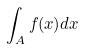<formula> <loc_0><loc_0><loc_500><loc_500>\int _ { A } f ( x ) d x</formula> 